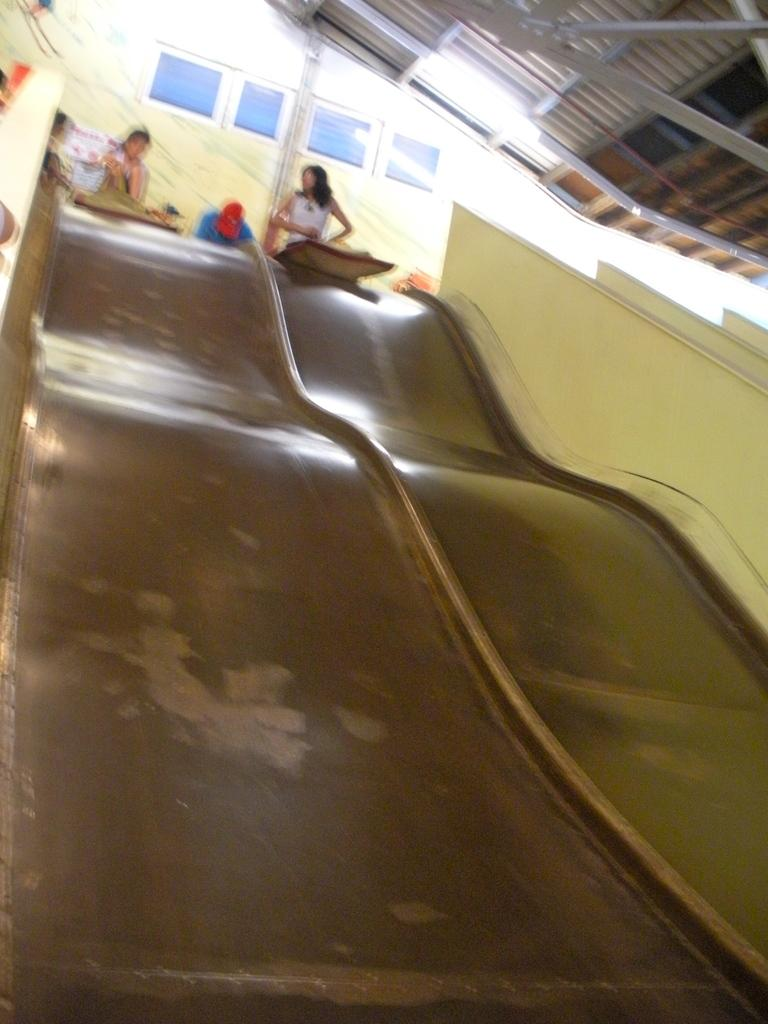How many people are in the image? There are people in the image, but the exact number is not specified. What are the people doing in the image? The people are sitting on a surface and are about to slide on the surface. What type of surface are the people sitting on? The specific type of surface is not mentioned in the facts. What type of letter is being written by the steam in the image? There is no steam or letter present in the image. How does the quartz affect the sliding surface in the image? There is no mention of quartz in the image or its potential effect on the sliding surface. 